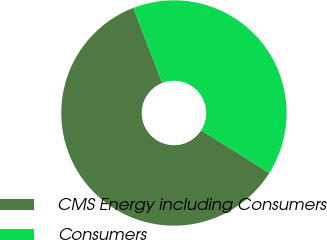<chart> <loc_0><loc_0><loc_500><loc_500><pie_chart><fcel>CMS Energy including Consumers<fcel>Consumers<nl><fcel>60.19%<fcel>39.81%<nl></chart> 